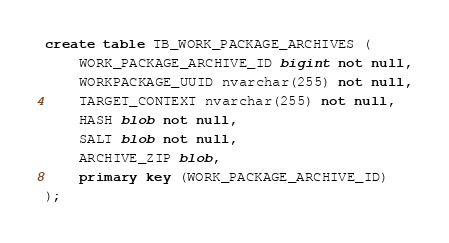<code> <loc_0><loc_0><loc_500><loc_500><_SQL_>create table TB_WORK_PACKAGE_ARCHIVES (
    WORK_PACKAGE_ARCHIVE_ID bigint not null,
    WORKPACKAGE_UUID nvarchar(255) not null,
    TARGET_CONTEXT nvarchar(255) not null,
    HASH blob not null,
    SALT blob not null,
    ARCHIVE_ZIP blob,
    primary key (WORK_PACKAGE_ARCHIVE_ID)
);</code> 